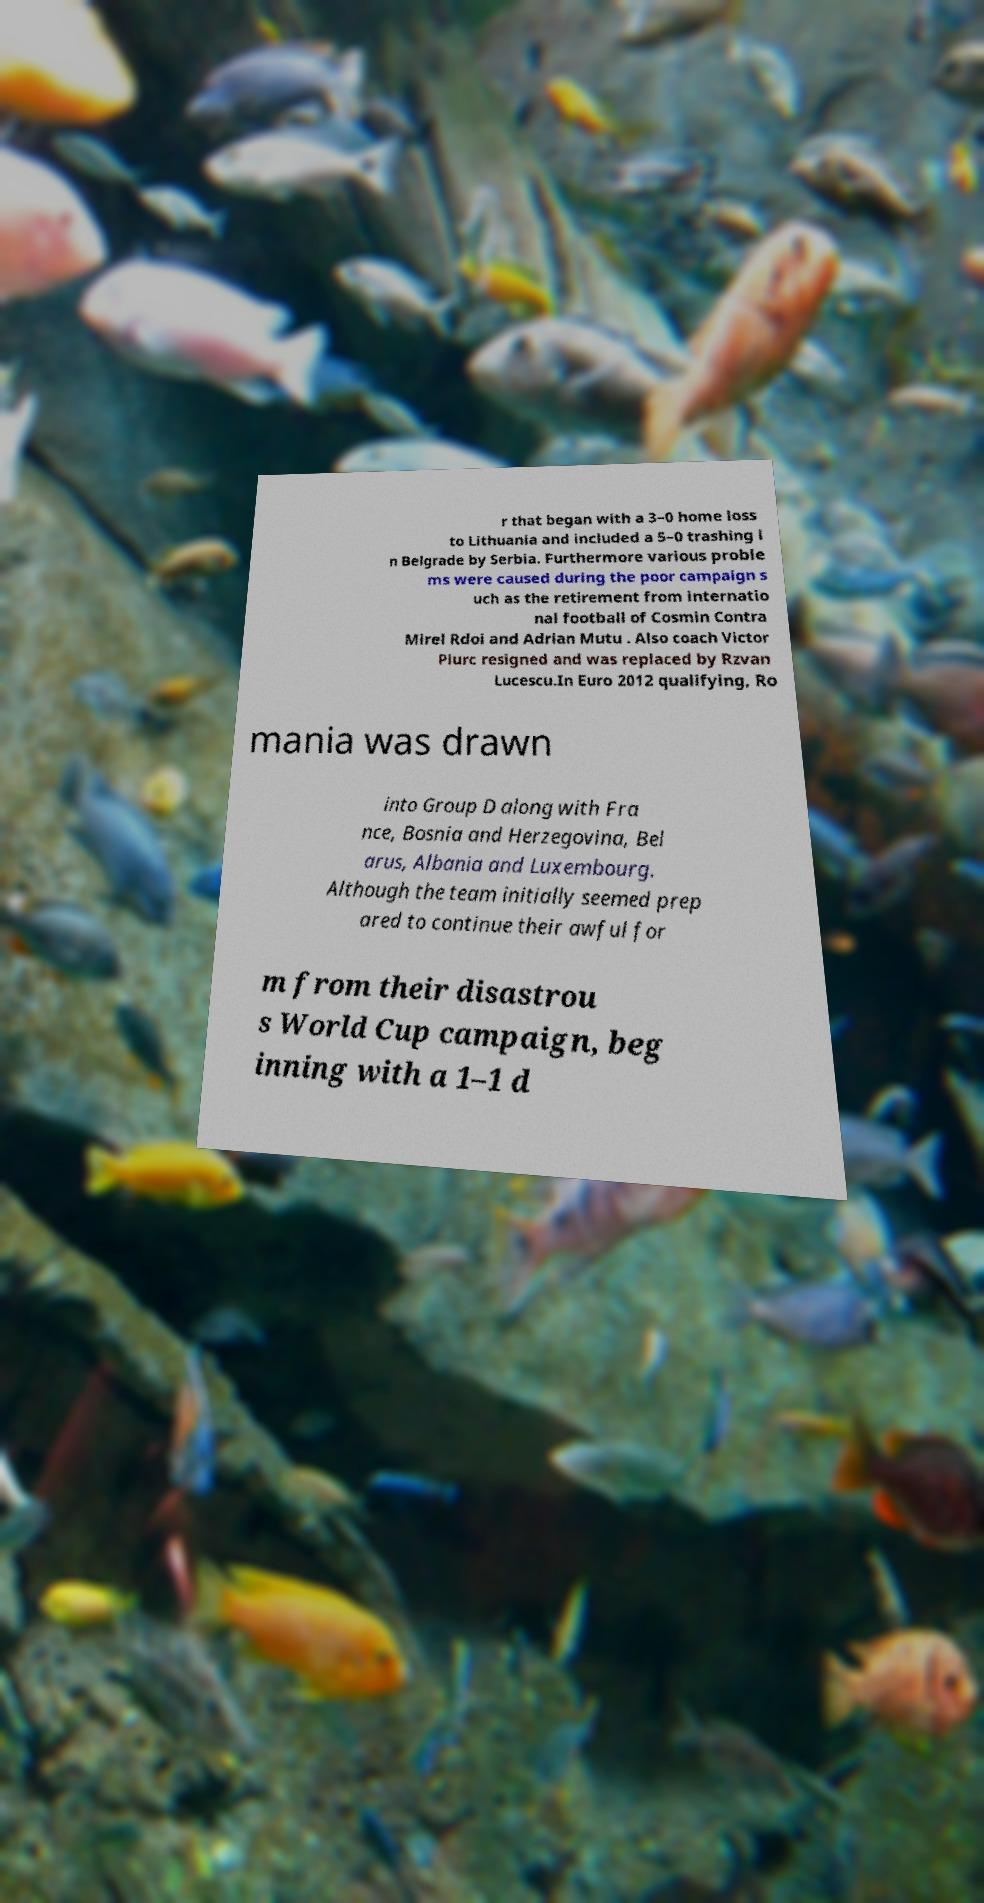Could you assist in decoding the text presented in this image and type it out clearly? r that began with a 3–0 home loss to Lithuania and included a 5–0 trashing i n Belgrade by Serbia. Furthermore various proble ms were caused during the poor campaign s uch as the retirement from internatio nal football of Cosmin Contra Mirel Rdoi and Adrian Mutu . Also coach Victor Piurc resigned and was replaced by Rzvan Lucescu.In Euro 2012 qualifying, Ro mania was drawn into Group D along with Fra nce, Bosnia and Herzegovina, Bel arus, Albania and Luxembourg. Although the team initially seemed prep ared to continue their awful for m from their disastrou s World Cup campaign, beg inning with a 1–1 d 